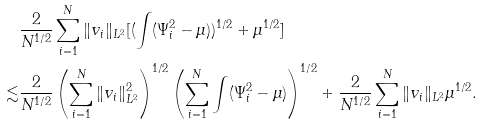Convert formula to latex. <formula><loc_0><loc_0><loc_500><loc_500>& \frac { 2 } { N ^ { 1 / 2 } } \sum _ { i = 1 } ^ { N } \| v _ { i } \| _ { L ^ { 2 } } [ ( \int ( \Psi _ { i } ^ { 2 } - \mu ) ) ^ { 1 / 2 } + \mu ^ { 1 / 2 } ] \\ \lesssim & \frac { 2 } { N ^ { 1 / 2 } } \left ( \sum _ { i = 1 } ^ { N } \| v _ { i } \| _ { L ^ { 2 } } ^ { 2 } \right ) ^ { 1 / 2 } \left ( \sum _ { i = 1 } ^ { N } \int ( \Psi _ { i } ^ { 2 } - \mu ) \right ) ^ { 1 / 2 } + \frac { 2 } { N ^ { 1 / 2 } } \sum _ { i = 1 } ^ { N } \| v _ { i } \| _ { L ^ { 2 } } \mu ^ { 1 / 2 } .</formula> 